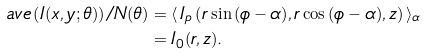Convert formula to latex. <formula><loc_0><loc_0><loc_500><loc_500>a v e \left ( I ( x , y ; \theta ) \right ) / N ( \theta ) & = \langle \, I _ { p } \left ( r \sin { ( \phi - \alpha ) } , r \cos { ( \phi - \alpha ) } , z \right ) \, \rangle _ { \alpha } \\ & = I _ { 0 } ( r , z ) .</formula> 